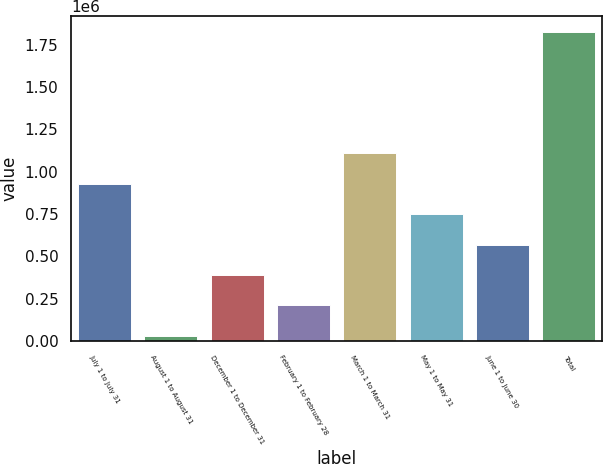Convert chart. <chart><loc_0><loc_0><loc_500><loc_500><bar_chart><fcel>July 1 to July 31<fcel>August 1 to August 31<fcel>December 1 to December 31<fcel>February 1 to February 28<fcel>March 1 to March 31<fcel>May 1 to May 31<fcel>June 1 to June 30<fcel>Total<nl><fcel>928204<fcel>30100<fcel>389341<fcel>209721<fcel>1.10782e+06<fcel>748583<fcel>568962<fcel>1.82631e+06<nl></chart> 